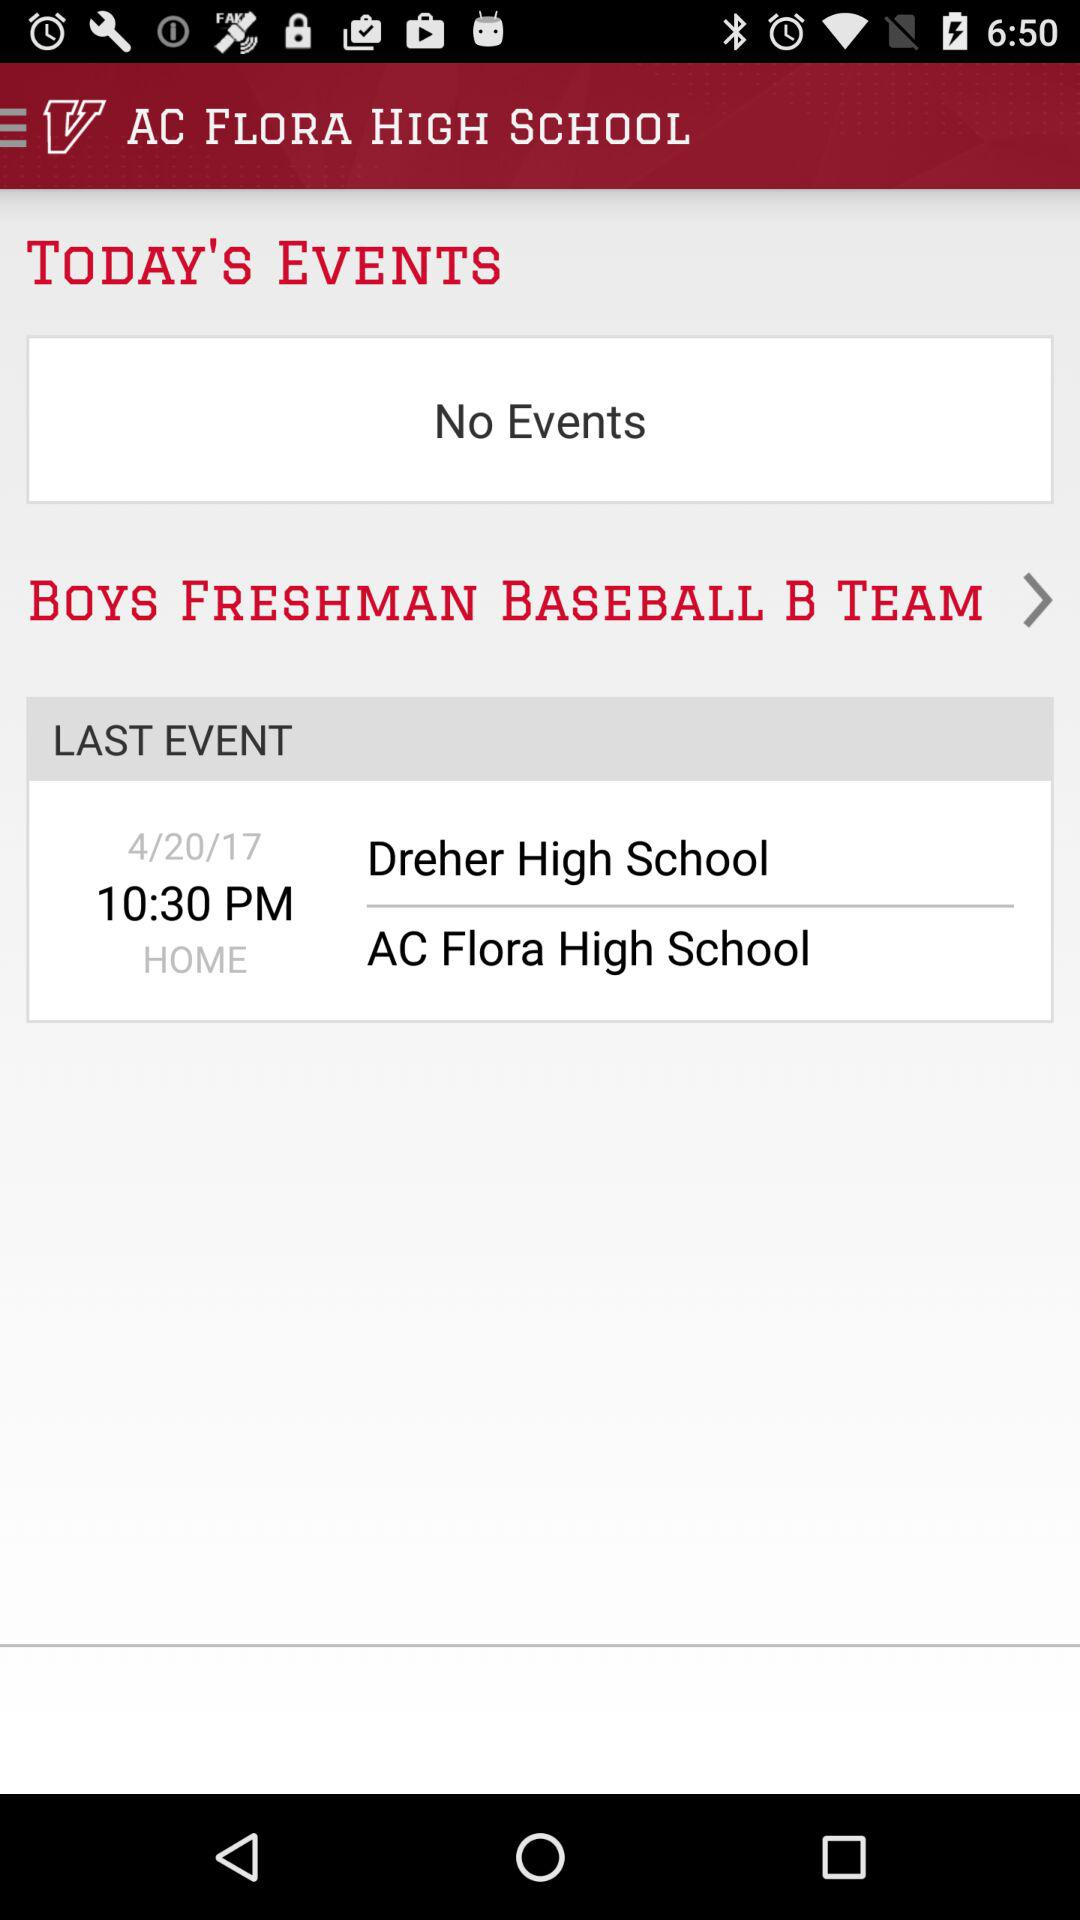Which teams were competing in the last event? The teams that were competing in the last event were "Dreher High School" and "AC Flora High School". 